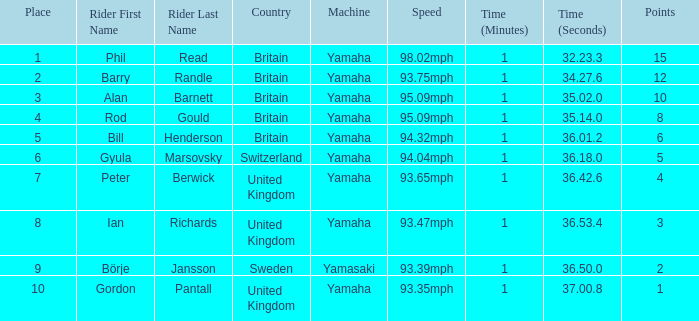What was the time for the man who scored 1 point? 1:37.00.8. 